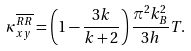Convert formula to latex. <formula><loc_0><loc_0><loc_500><loc_500>\kappa _ { x y } ^ { \overline { R R } } = \left ( 1 - \frac { 3 k } { k + 2 } \right ) \frac { \pi ^ { 2 } k _ { B } ^ { 2 } } { 3 h } T .</formula> 